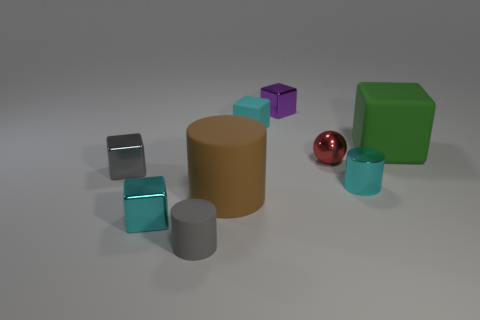Are there any balls that are in front of the small cyan cube that is in front of the tiny gray metal thing?
Your response must be concise. No. There is a sphere that is the same size as the cyan matte cube; what material is it?
Give a very brief answer. Metal. Is there a yellow metallic object of the same size as the cyan rubber object?
Your response must be concise. No. There is a tiny cyan object that is to the right of the small red ball; what material is it?
Give a very brief answer. Metal. Are the tiny cyan cube that is behind the green object and the green object made of the same material?
Provide a succinct answer. Yes. What is the shape of the red thing that is the same size as the purple object?
Offer a terse response. Sphere. How many small metallic blocks are the same color as the metal sphere?
Make the answer very short. 0. Is the number of tiny metallic cubes that are behind the gray matte cylinder less than the number of small cyan metal cylinders that are behind the sphere?
Give a very brief answer. No. There is a tiny rubber cube; are there any small cyan matte blocks on the right side of it?
Provide a short and direct response. No. There is a cube on the right side of the metallic cube behind the tiny ball; is there a small gray matte cylinder on the right side of it?
Provide a short and direct response. No. 